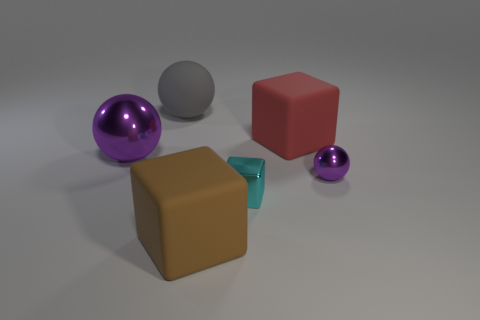Are there more small green rubber objects than red matte things? Based on the image, there is an equal number of small green rubber objects and red matte things, both being one of each. 